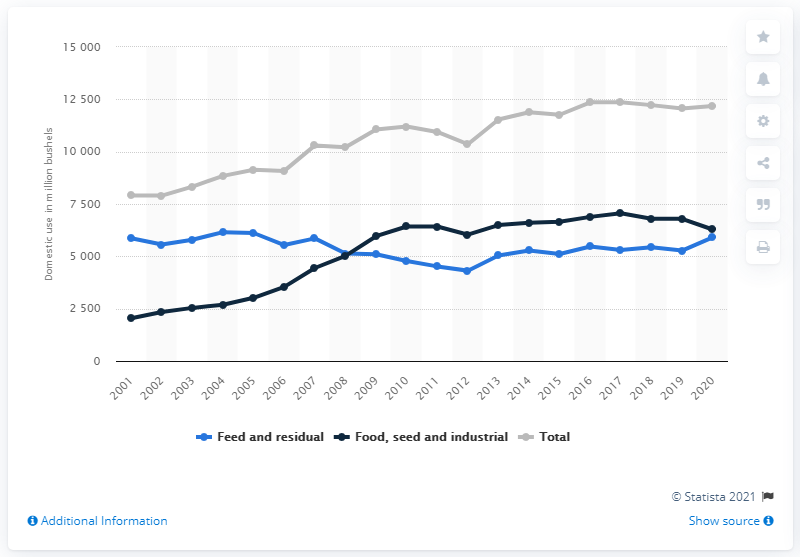Indicate a few pertinent items in this graphic. In 2019, a total of 5,275 bushels of corn were used for feed and residual purposes in the United States. 